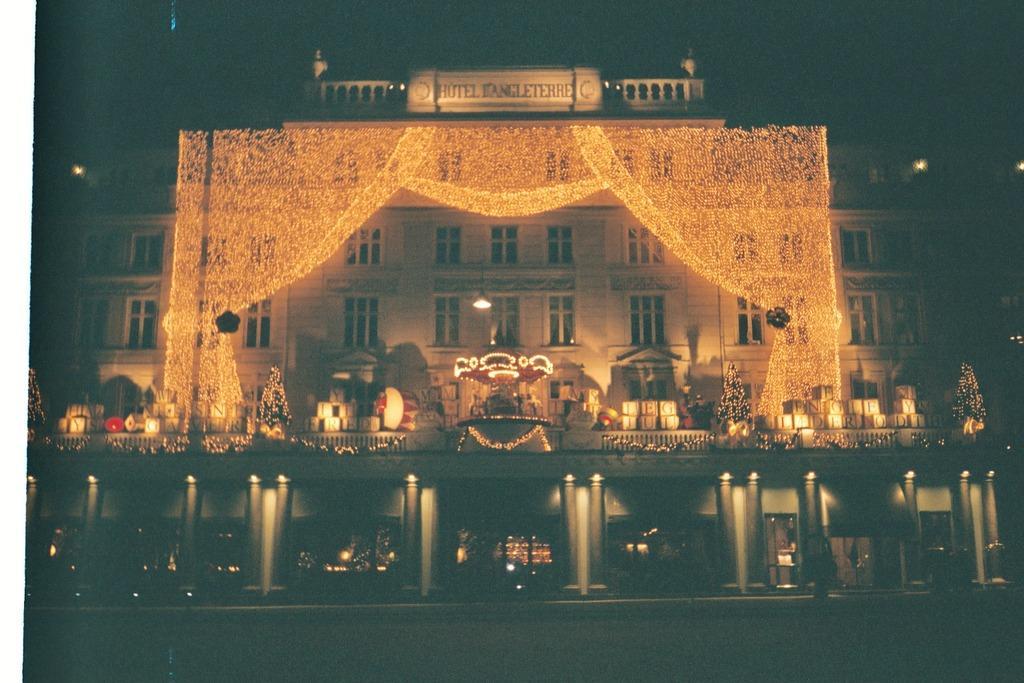Could you give a brief overview of what you see in this image? In this picture there is a building which is decorated with lights and there is something written above it. 